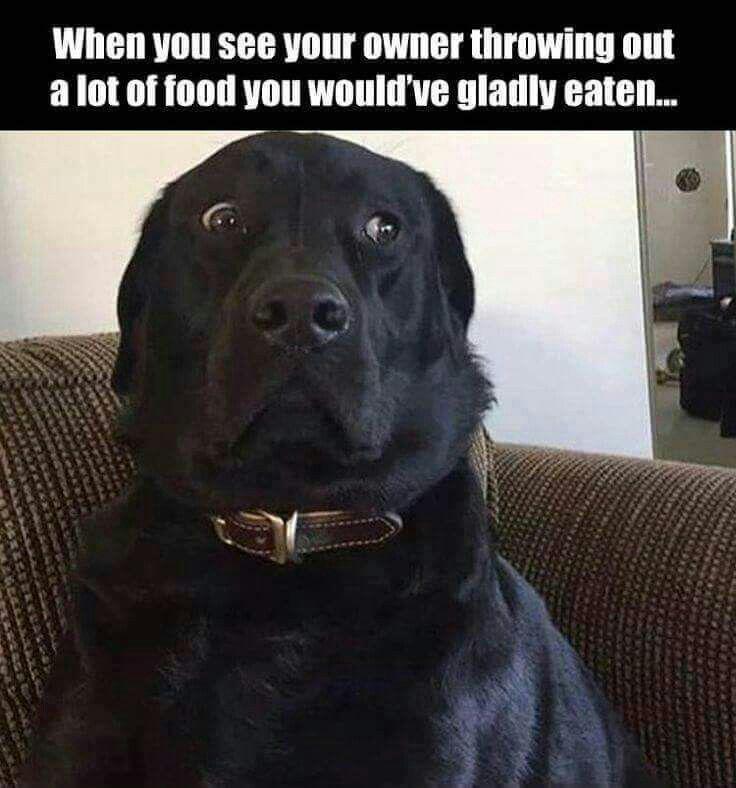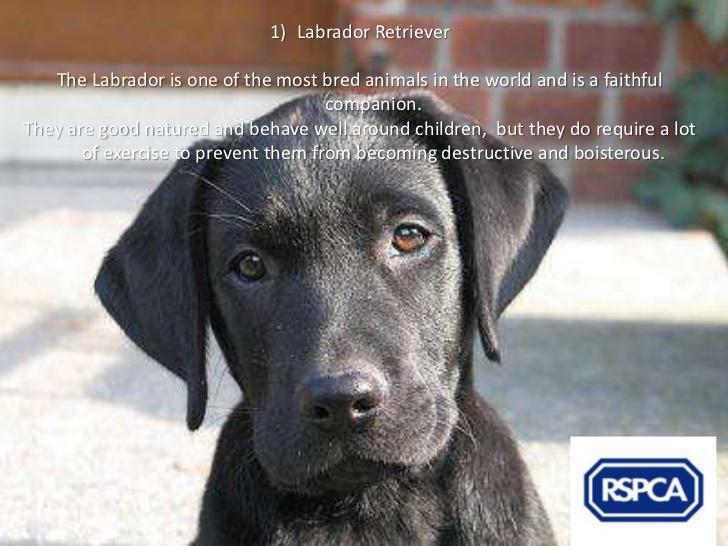The first image is the image on the left, the second image is the image on the right. Evaluate the accuracy of this statement regarding the images: "One of the images shows a dog with its tongue sticking out.". Is it true? Answer yes or no. No. The first image is the image on the left, the second image is the image on the right. Given the left and right images, does the statement "Both images are a head shot of one dog with its mouth closed." hold true? Answer yes or no. Yes. 